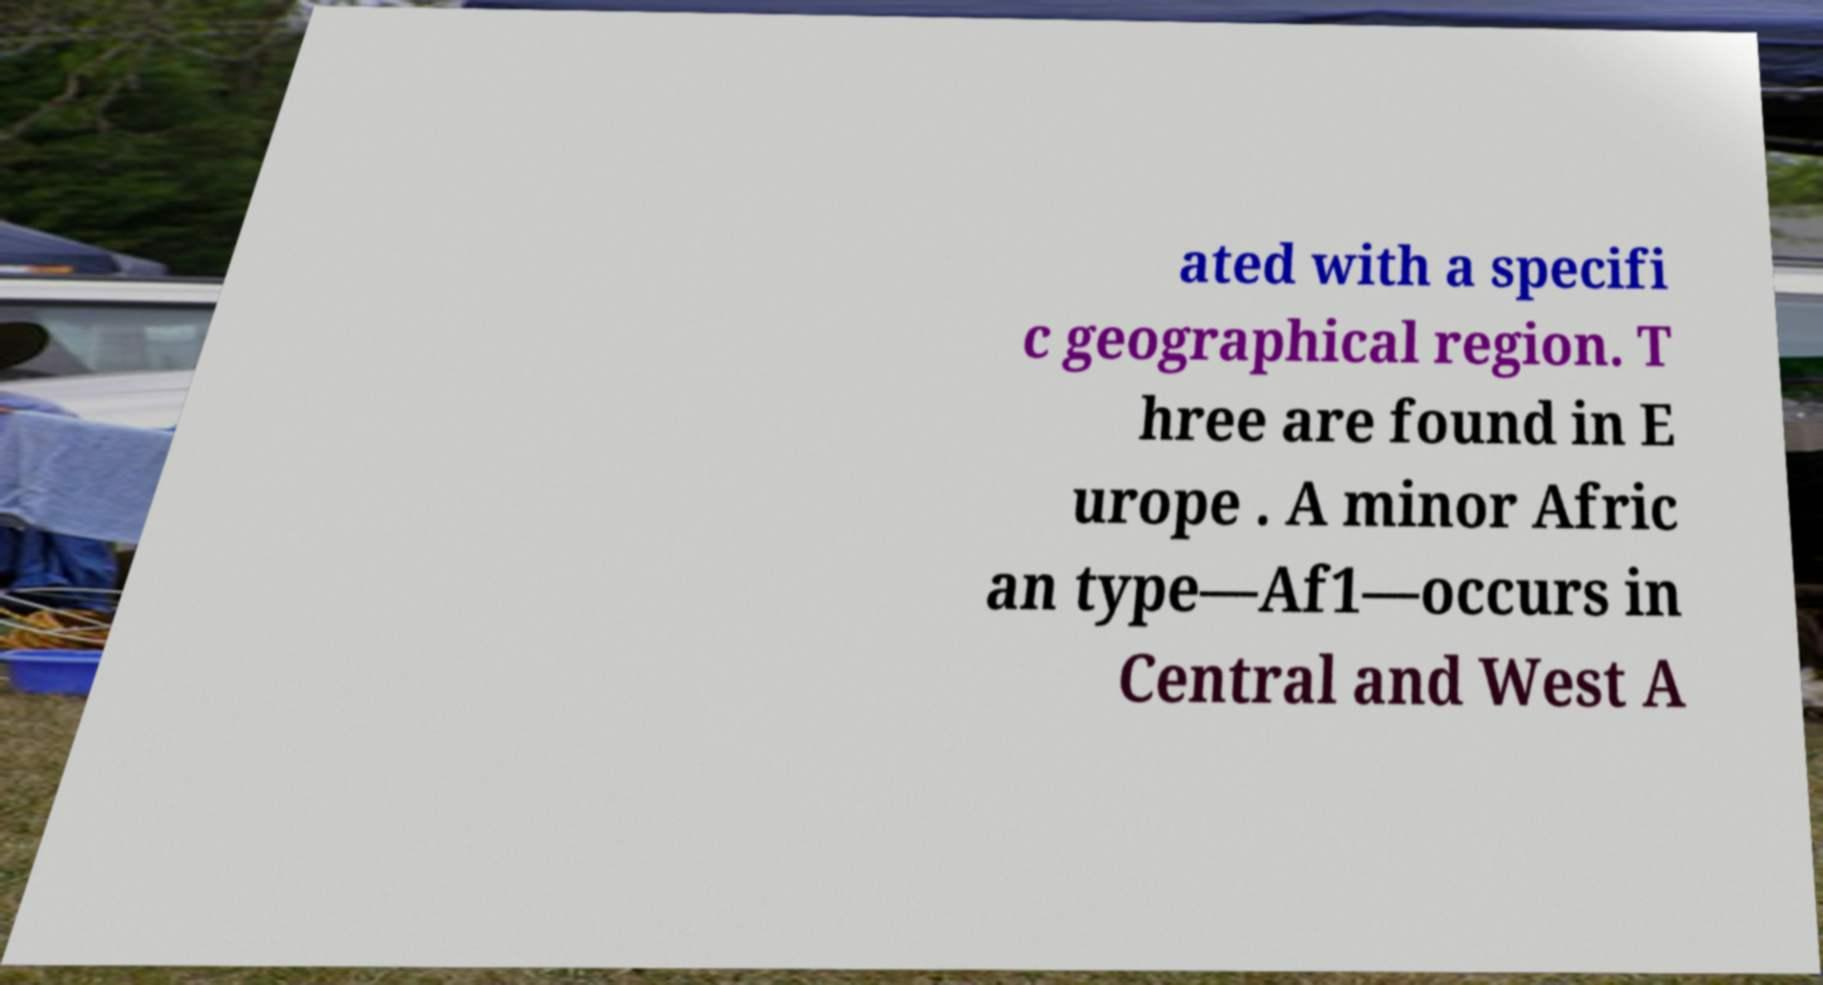Can you read and provide the text displayed in the image?This photo seems to have some interesting text. Can you extract and type it out for me? ated with a specifi c geographical region. T hree are found in E urope . A minor Afric an type—Af1—occurs in Central and West A 